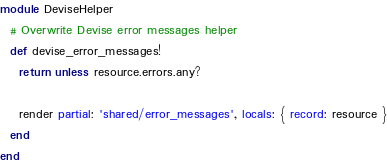<code> <loc_0><loc_0><loc_500><loc_500><_Ruby_>module DeviseHelper
  # Overwrite Devise error messages helper
  def devise_error_messages!
    return unless resource.errors.any?

    render partial: 'shared/error_messages', locals: { record: resource }
  end
end
</code> 